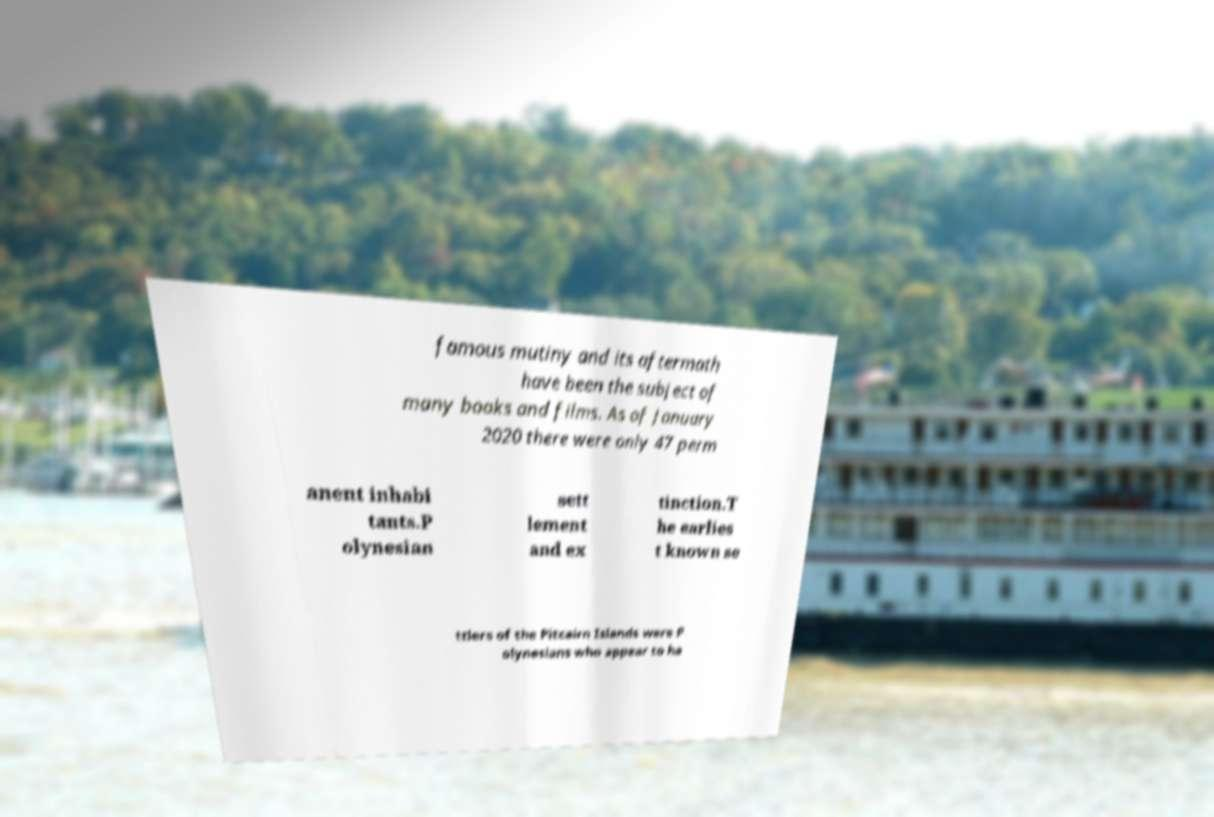Can you read and provide the text displayed in the image?This photo seems to have some interesting text. Can you extract and type it out for me? famous mutiny and its aftermath have been the subject of many books and films. As of January 2020 there were only 47 perm anent inhabi tants.P olynesian sett lement and ex tinction.T he earlies t known se ttlers of the Pitcairn Islands were P olynesians who appear to ha 